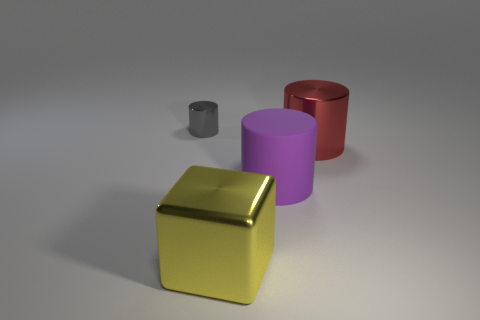How many metal things are in front of the metallic cylinder that is on the right side of the gray thing?
Provide a short and direct response. 1. Are there more small gray metal cylinders that are right of the cube than big cylinders that are to the left of the big red metal cylinder?
Keep it short and to the point. No. What material is the block?
Your response must be concise. Metal. Are there any gray shiny things of the same size as the red metallic cylinder?
Keep it short and to the point. No. What is the material of the purple cylinder that is the same size as the shiny block?
Keep it short and to the point. Rubber. What number of large rubber objects are there?
Offer a very short reply. 1. What is the size of the thing that is behind the red metallic cylinder?
Provide a short and direct response. Small. Is the number of cylinders that are to the left of the red object the same as the number of yellow blocks?
Keep it short and to the point. No. Is there another large red object that has the same shape as the matte object?
Offer a terse response. Yes. There is a metallic object that is in front of the gray metallic thing and on the left side of the purple rubber cylinder; what shape is it?
Provide a succinct answer. Cube. 